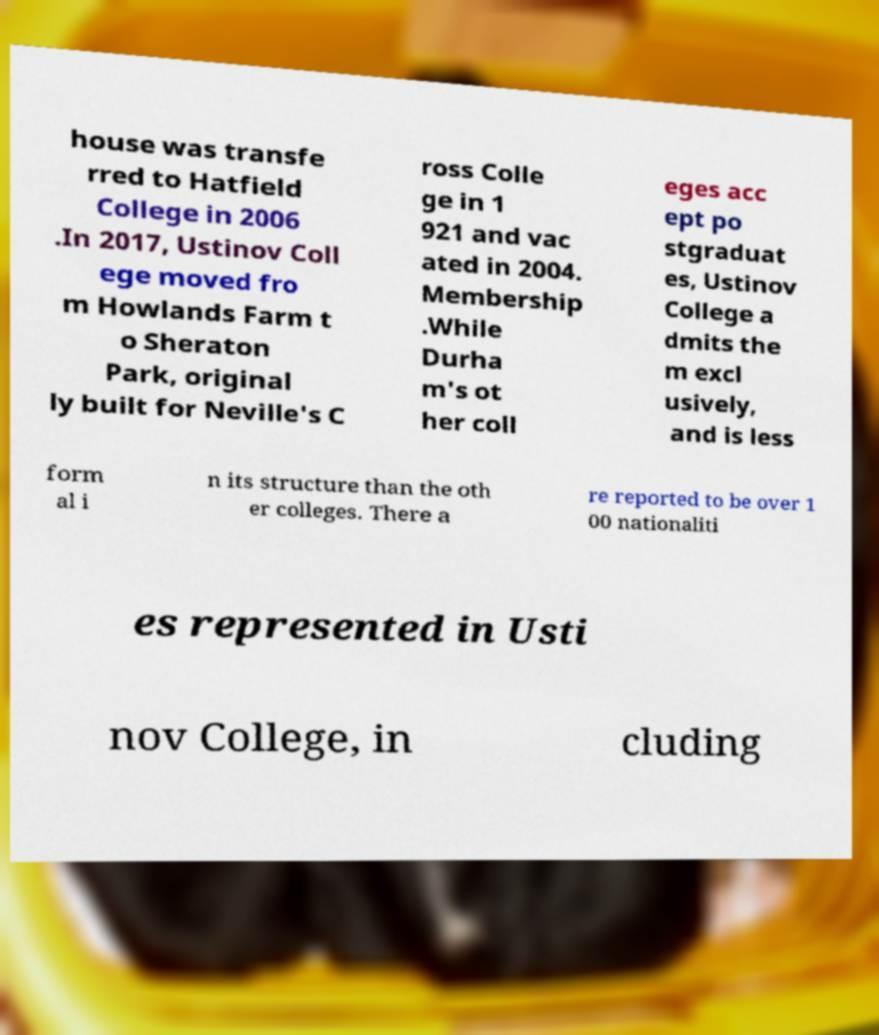There's text embedded in this image that I need extracted. Can you transcribe it verbatim? house was transfe rred to Hatfield College in 2006 .In 2017, Ustinov Coll ege moved fro m Howlands Farm t o Sheraton Park, original ly built for Neville's C ross Colle ge in 1 921 and vac ated in 2004. Membership .While Durha m's ot her coll eges acc ept po stgraduat es, Ustinov College a dmits the m excl usively, and is less form al i n its structure than the oth er colleges. There a re reported to be over 1 00 nationaliti es represented in Usti nov College, in cluding 